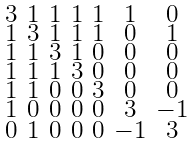<formula> <loc_0><loc_0><loc_500><loc_500>\begin{smallmatrix} 3 & 1 & 1 & 1 & 1 & 1 & 0 \\ 1 & 3 & 1 & 1 & 1 & 0 & 1 \\ 1 & 1 & 3 & 1 & 0 & 0 & 0 \\ 1 & 1 & 1 & 3 & 0 & 0 & 0 \\ 1 & 1 & 0 & 0 & 3 & 0 & 0 \\ 1 & 0 & 0 & 0 & 0 & 3 & - 1 \\ 0 & 1 & 0 & 0 & 0 & - 1 & 3 \end{smallmatrix}</formula> 